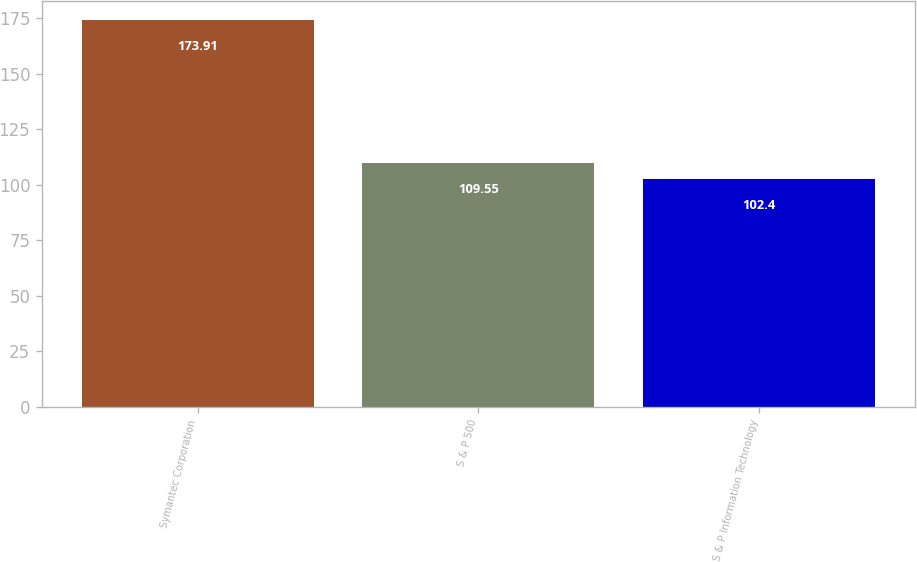Convert chart. <chart><loc_0><loc_0><loc_500><loc_500><bar_chart><fcel>Symantec Corporation<fcel>S & P 500<fcel>S & P Information Technology<nl><fcel>173.91<fcel>109.55<fcel>102.4<nl></chart> 